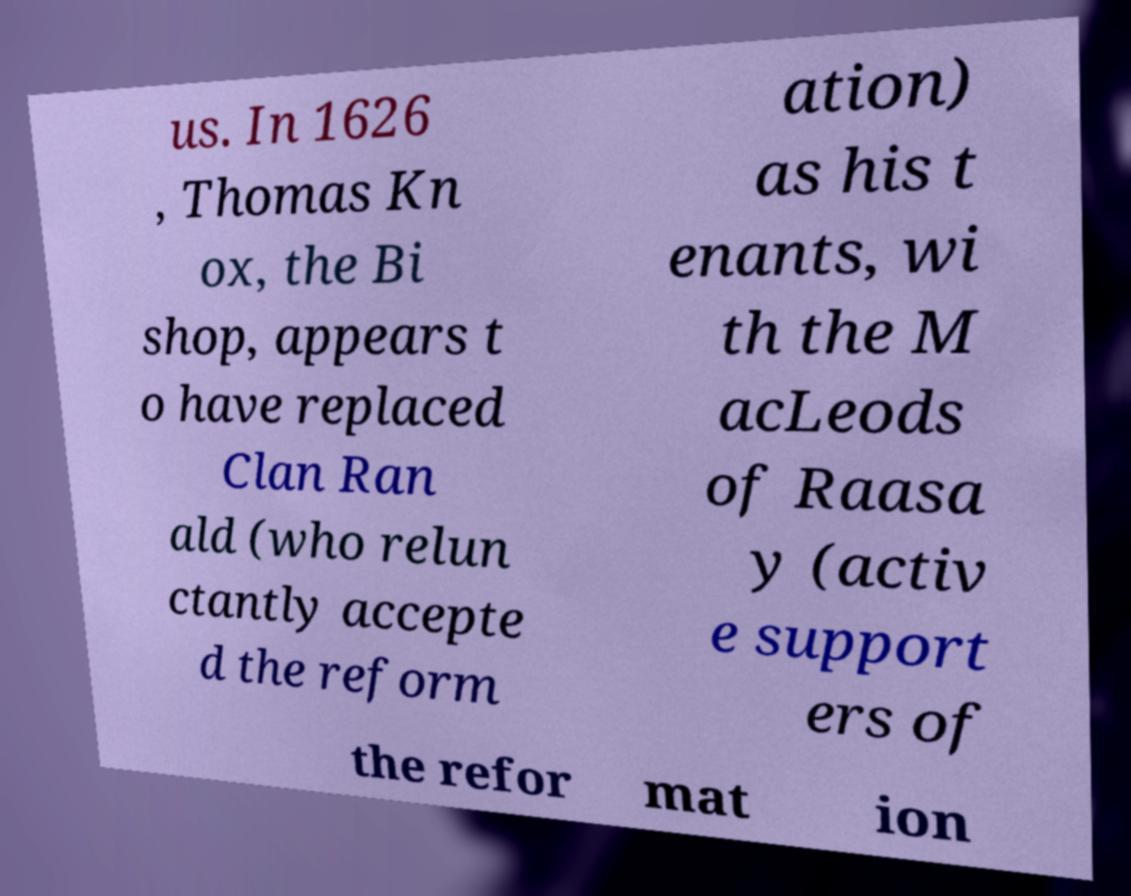Could you extract and type out the text from this image? us. In 1626 , Thomas Kn ox, the Bi shop, appears t o have replaced Clan Ran ald (who relun ctantly accepte d the reform ation) as his t enants, wi th the M acLeods of Raasa y (activ e support ers of the refor mat ion 